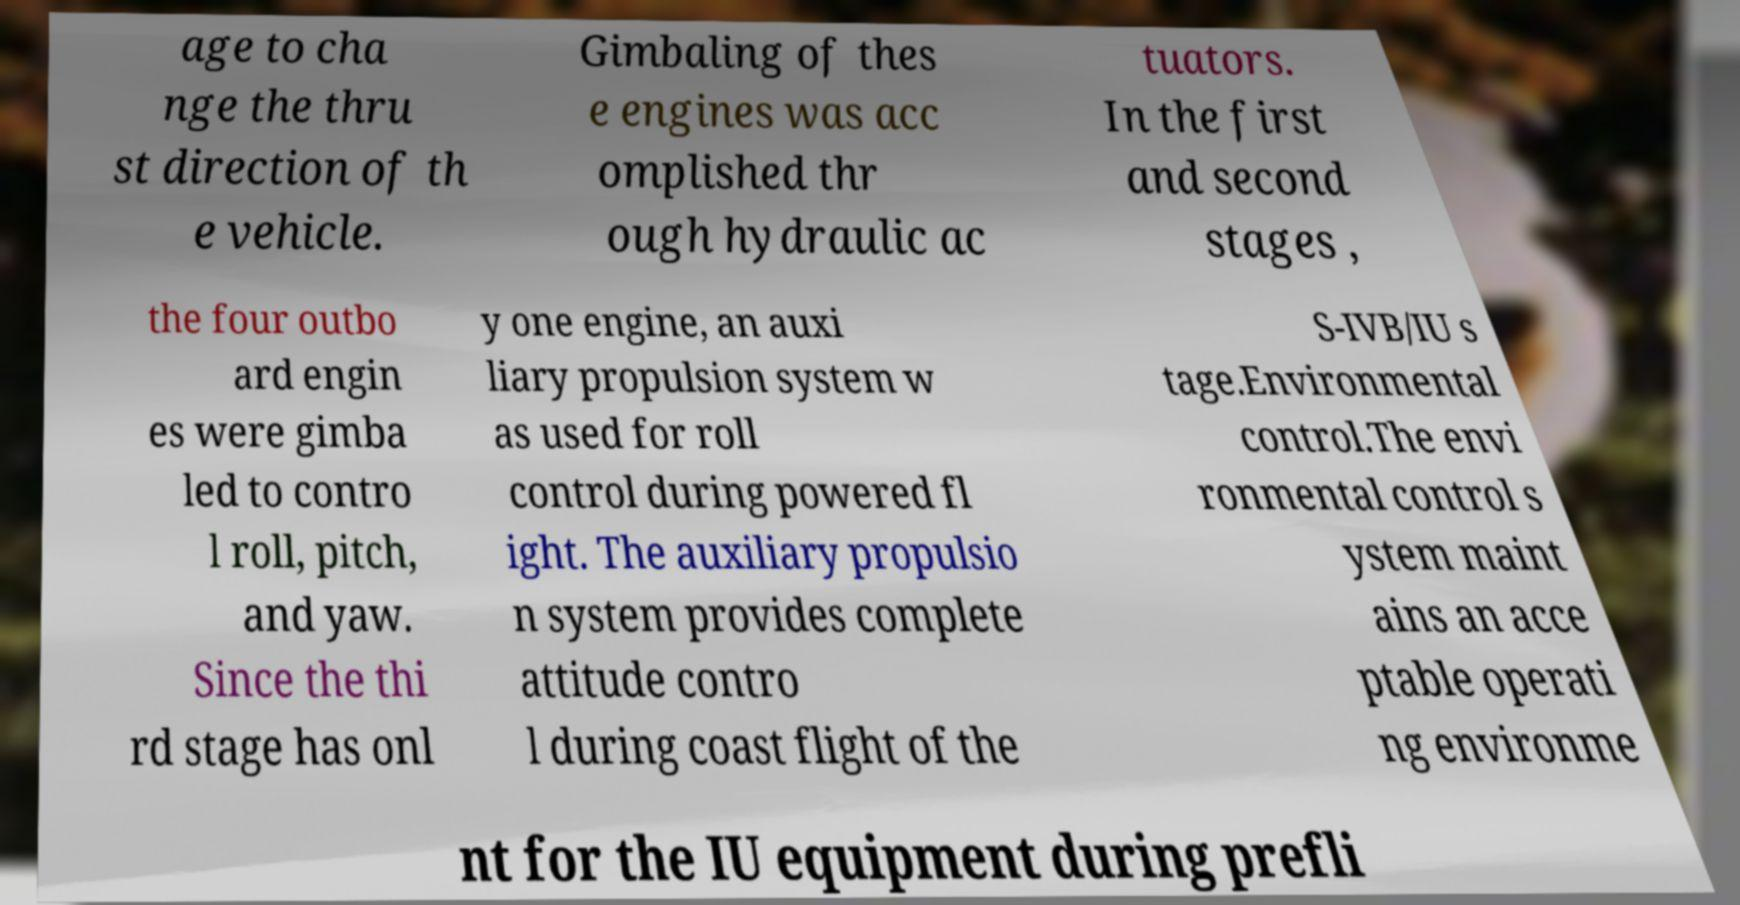Can you read and provide the text displayed in the image?This photo seems to have some interesting text. Can you extract and type it out for me? age to cha nge the thru st direction of th e vehicle. Gimbaling of thes e engines was acc omplished thr ough hydraulic ac tuators. In the first and second stages , the four outbo ard engin es were gimba led to contro l roll, pitch, and yaw. Since the thi rd stage has onl y one engine, an auxi liary propulsion system w as used for roll control during powered fl ight. The auxiliary propulsio n system provides complete attitude contro l during coast flight of the S-IVB/IU s tage.Environmental control.The envi ronmental control s ystem maint ains an acce ptable operati ng environme nt for the IU equipment during prefli 